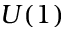<formula> <loc_0><loc_0><loc_500><loc_500>U ( 1 )</formula> 